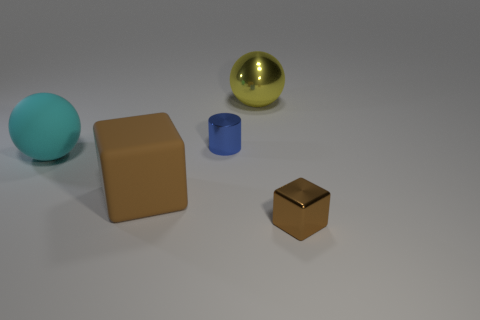Subtract all yellow balls. How many balls are left? 1 Add 3 blue metallic cylinders. How many objects exist? 8 Subtract all brown cubes. How many cyan balls are left? 1 Subtract all cylinders. How many objects are left? 4 Subtract all big yellow rubber spheres. Subtract all large brown matte objects. How many objects are left? 4 Add 3 large rubber spheres. How many large rubber spheres are left? 4 Add 2 matte balls. How many matte balls exist? 3 Subtract 1 yellow balls. How many objects are left? 4 Subtract all gray cylinders. Subtract all gray cubes. How many cylinders are left? 1 